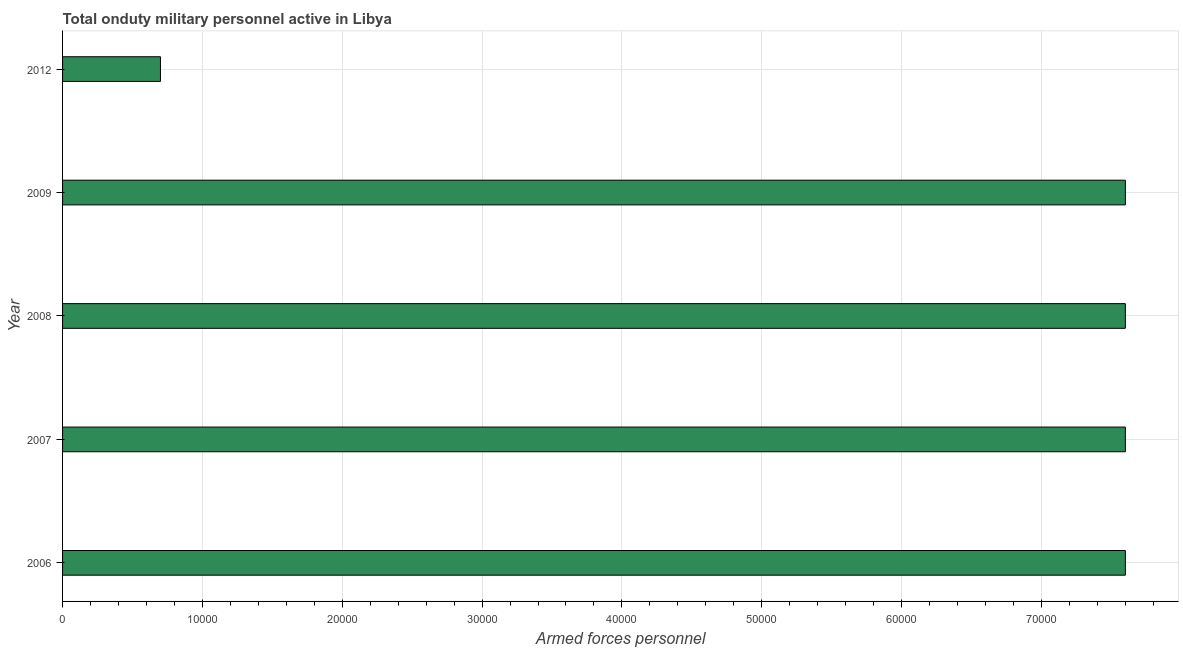Does the graph contain any zero values?
Provide a succinct answer. No. What is the title of the graph?
Give a very brief answer. Total onduty military personnel active in Libya. What is the label or title of the X-axis?
Keep it short and to the point. Armed forces personnel. What is the label or title of the Y-axis?
Offer a very short reply. Year. What is the number of armed forces personnel in 2008?
Keep it short and to the point. 7.60e+04. Across all years, what is the maximum number of armed forces personnel?
Your answer should be very brief. 7.60e+04. Across all years, what is the minimum number of armed forces personnel?
Provide a succinct answer. 7000. What is the sum of the number of armed forces personnel?
Offer a terse response. 3.11e+05. What is the difference between the number of armed forces personnel in 2008 and 2012?
Your answer should be compact. 6.90e+04. What is the average number of armed forces personnel per year?
Provide a succinct answer. 6.22e+04. What is the median number of armed forces personnel?
Give a very brief answer. 7.60e+04. What is the ratio of the number of armed forces personnel in 2009 to that in 2012?
Offer a very short reply. 10.86. Is the number of armed forces personnel in 2006 less than that in 2008?
Offer a terse response. No. Is the sum of the number of armed forces personnel in 2007 and 2012 greater than the maximum number of armed forces personnel across all years?
Ensure brevity in your answer.  Yes. What is the difference between the highest and the lowest number of armed forces personnel?
Offer a very short reply. 6.90e+04. What is the difference between two consecutive major ticks on the X-axis?
Your answer should be compact. 10000. What is the Armed forces personnel of 2006?
Keep it short and to the point. 7.60e+04. What is the Armed forces personnel of 2007?
Make the answer very short. 7.60e+04. What is the Armed forces personnel of 2008?
Offer a terse response. 7.60e+04. What is the Armed forces personnel in 2009?
Give a very brief answer. 7.60e+04. What is the Armed forces personnel in 2012?
Your response must be concise. 7000. What is the difference between the Armed forces personnel in 2006 and 2008?
Keep it short and to the point. 0. What is the difference between the Armed forces personnel in 2006 and 2012?
Ensure brevity in your answer.  6.90e+04. What is the difference between the Armed forces personnel in 2007 and 2009?
Your answer should be very brief. 0. What is the difference between the Armed forces personnel in 2007 and 2012?
Provide a succinct answer. 6.90e+04. What is the difference between the Armed forces personnel in 2008 and 2009?
Keep it short and to the point. 0. What is the difference between the Armed forces personnel in 2008 and 2012?
Provide a short and direct response. 6.90e+04. What is the difference between the Armed forces personnel in 2009 and 2012?
Provide a short and direct response. 6.90e+04. What is the ratio of the Armed forces personnel in 2006 to that in 2012?
Your answer should be very brief. 10.86. What is the ratio of the Armed forces personnel in 2007 to that in 2009?
Keep it short and to the point. 1. What is the ratio of the Armed forces personnel in 2007 to that in 2012?
Make the answer very short. 10.86. What is the ratio of the Armed forces personnel in 2008 to that in 2009?
Give a very brief answer. 1. What is the ratio of the Armed forces personnel in 2008 to that in 2012?
Make the answer very short. 10.86. What is the ratio of the Armed forces personnel in 2009 to that in 2012?
Give a very brief answer. 10.86. 